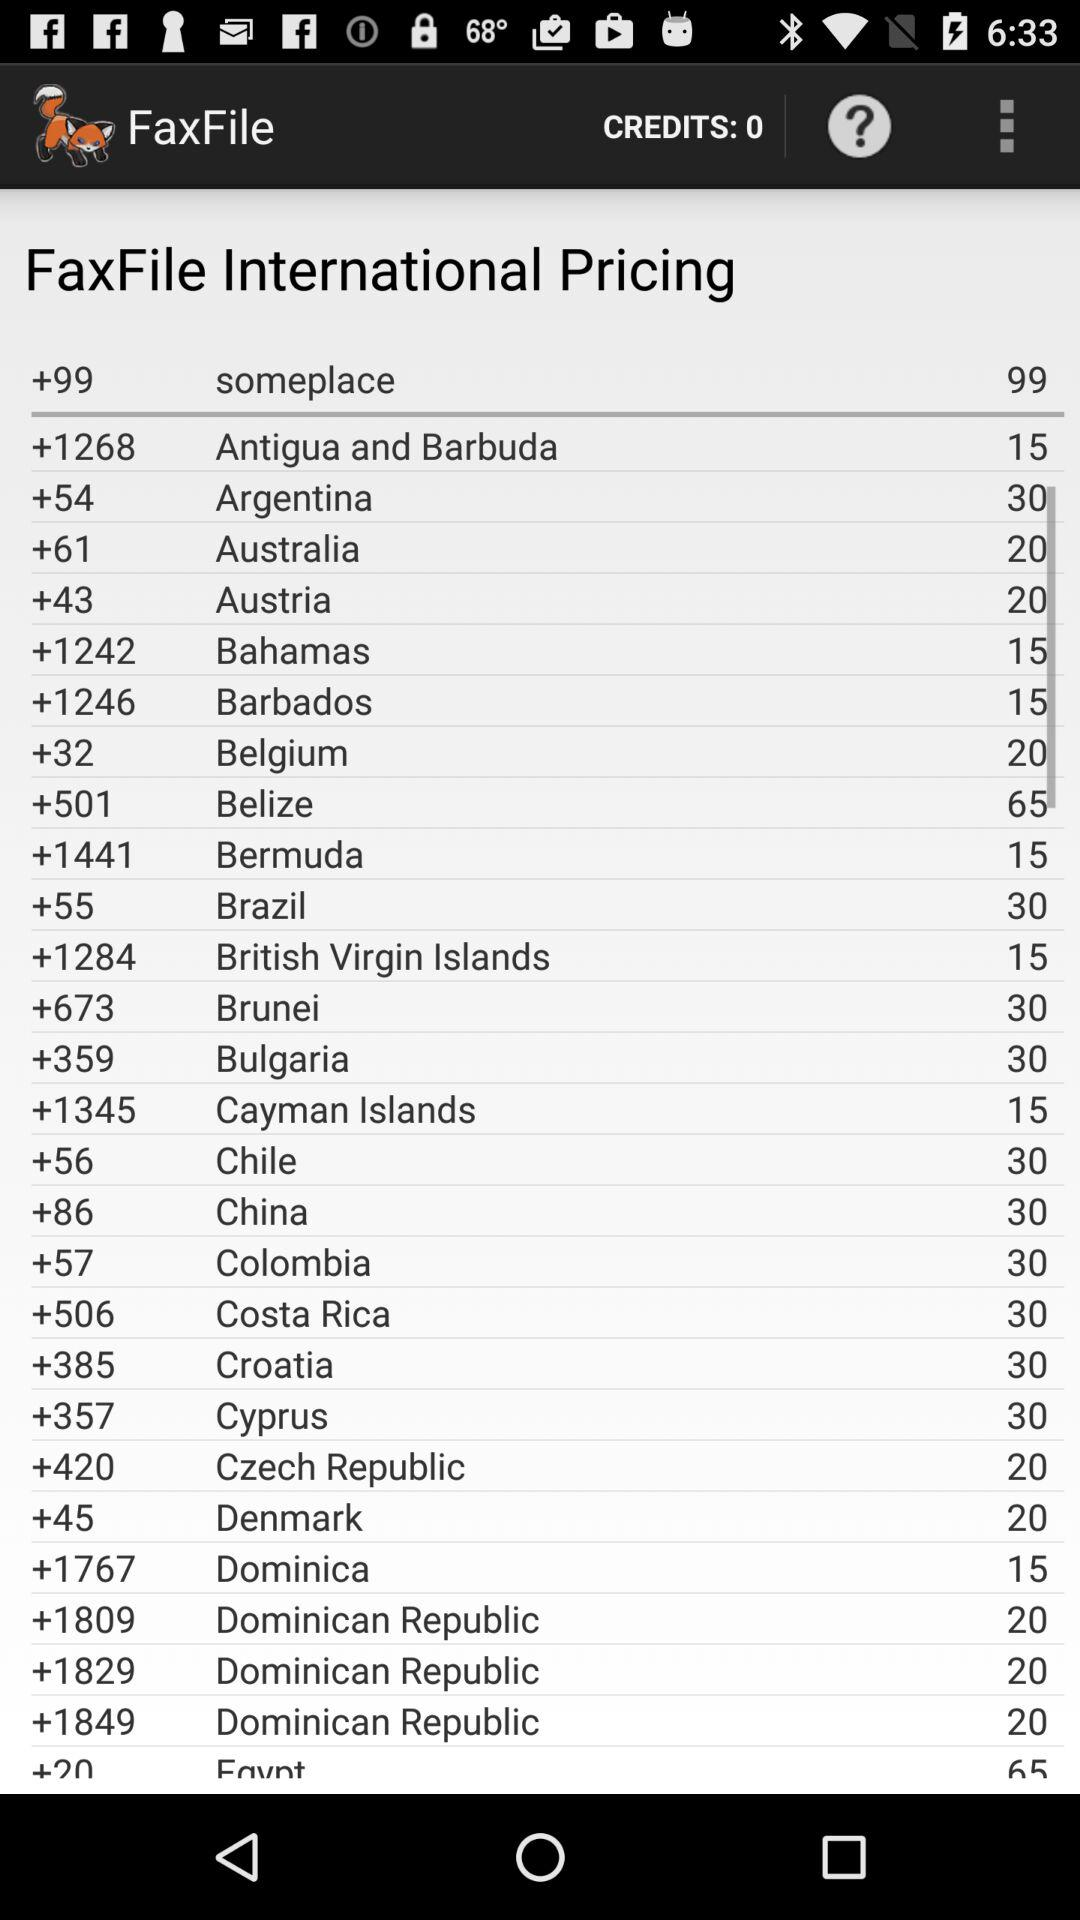How many credits are there? There are 0 credits. 